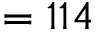<formula> <loc_0><loc_0><loc_500><loc_500>= 1 1 4</formula> 